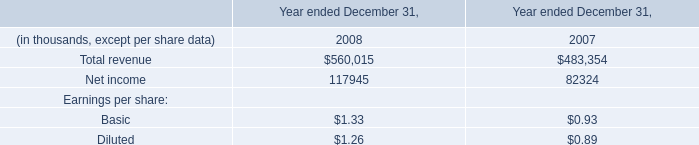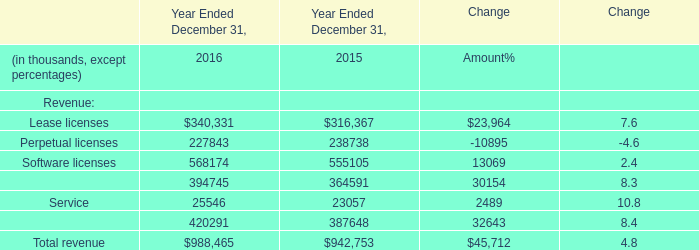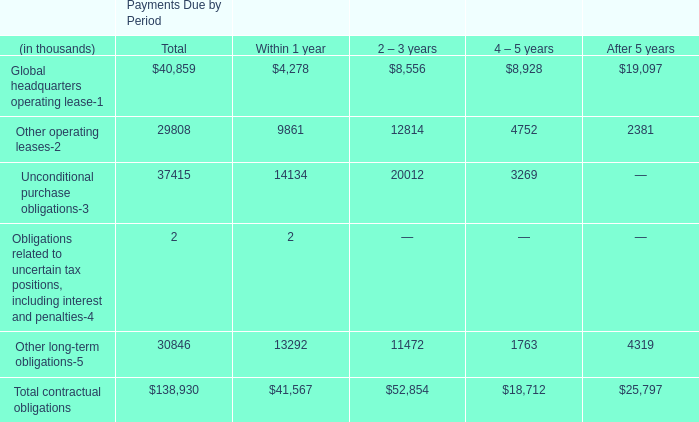what's the total amount of Maintenance of Year Ended December 31, 2016, and Net income of data 1 2007 ? 
Computations: (394745.0 + 82324.0)
Answer: 477069.0. 